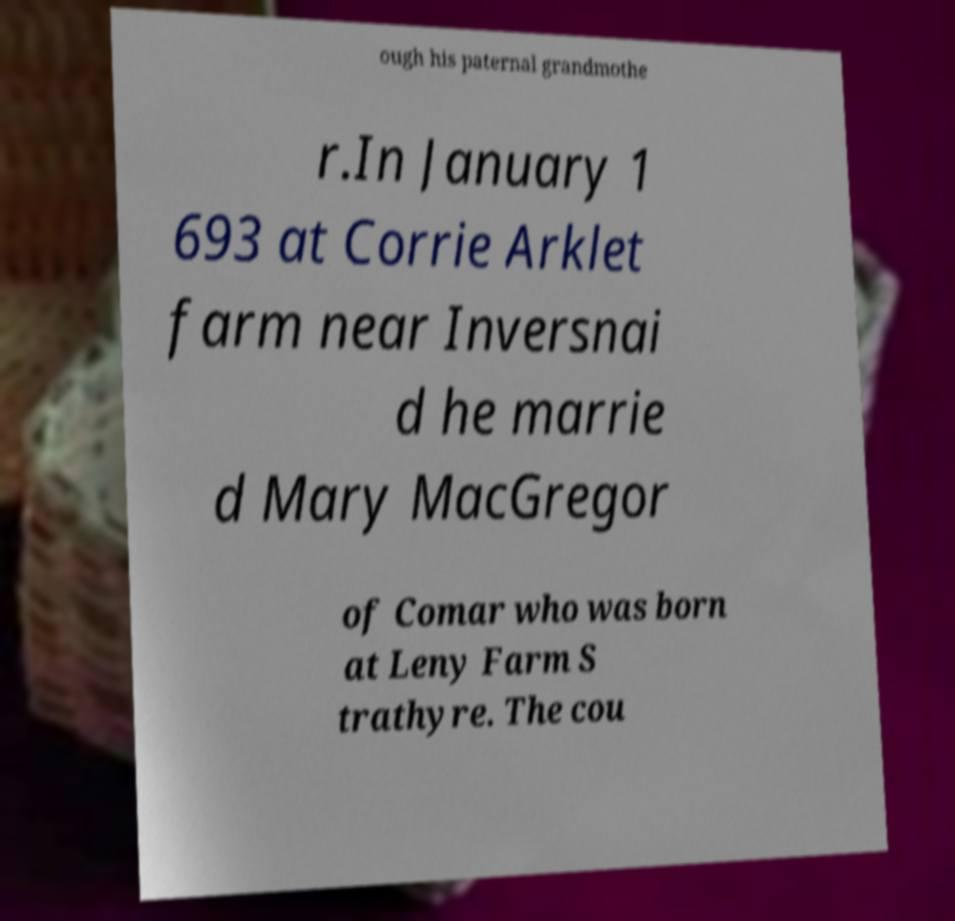Could you assist in decoding the text presented in this image and type it out clearly? ough his paternal grandmothe r.In January 1 693 at Corrie Arklet farm near Inversnai d he marrie d Mary MacGregor of Comar who was born at Leny Farm S trathyre. The cou 